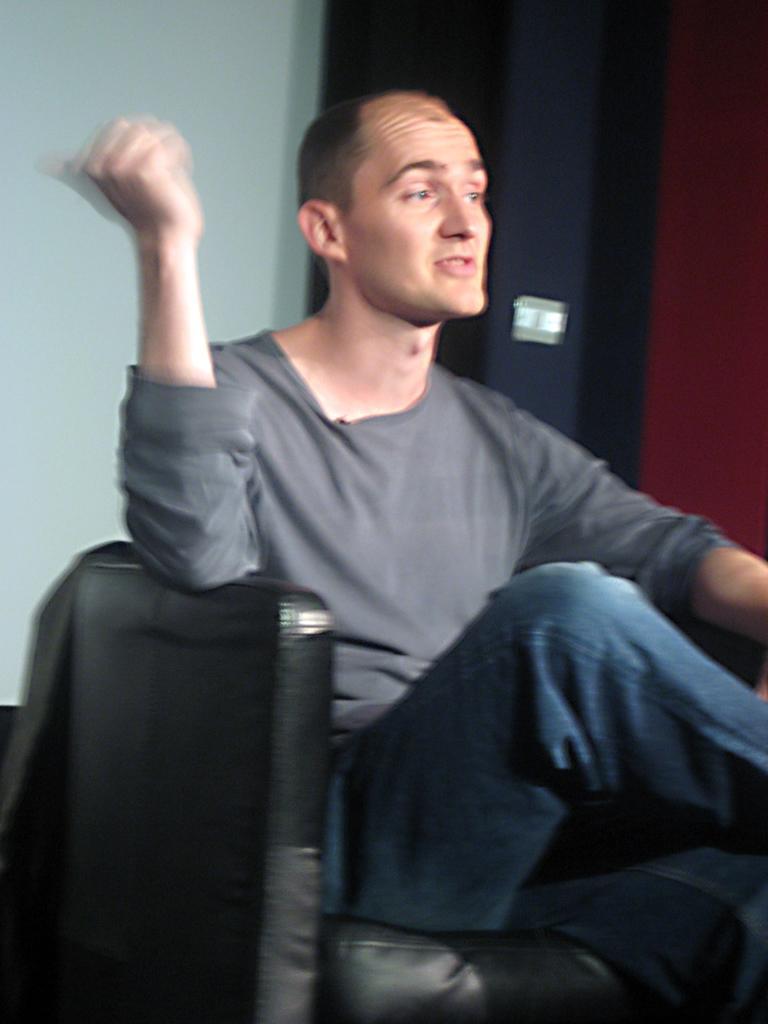Describe this image in one or two sentences. In this image a person is sitting on the chair. Behind him there is a wall. 